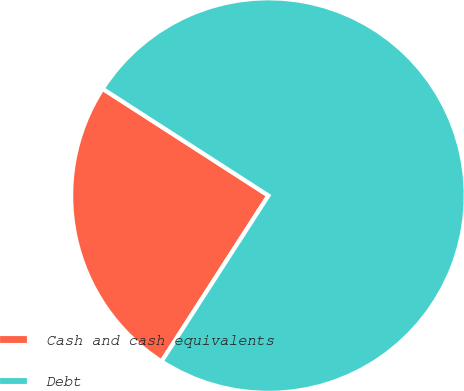Convert chart to OTSL. <chart><loc_0><loc_0><loc_500><loc_500><pie_chart><fcel>Cash and cash equivalents<fcel>Debt<nl><fcel>25.0%<fcel>75.0%<nl></chart> 